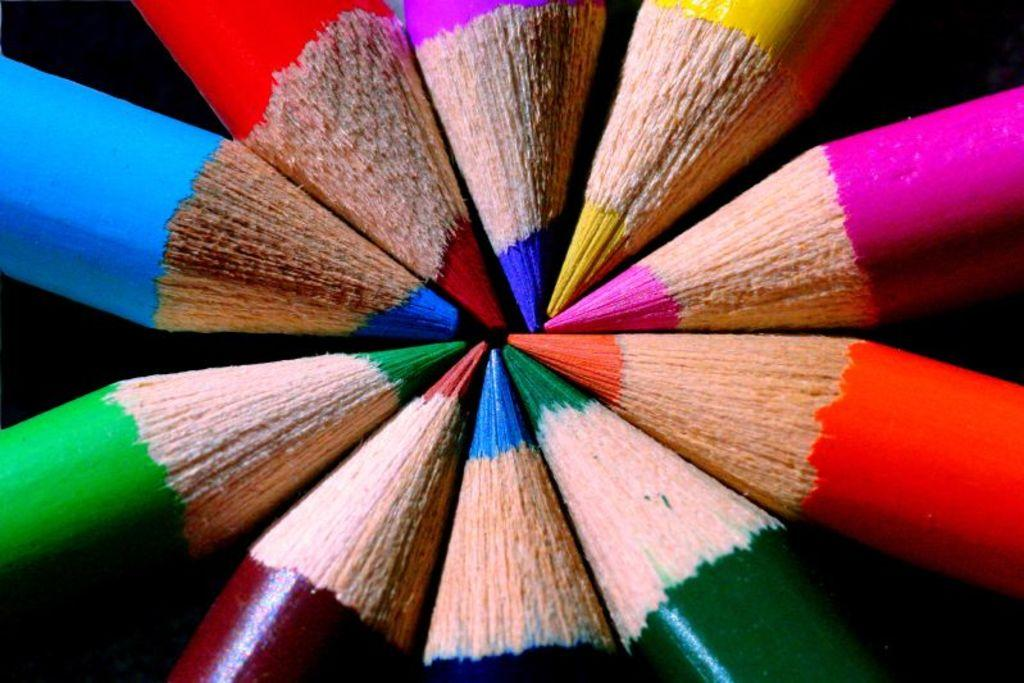What objects are present in the image? There are color pencils in the image. How are the color pencils arranged? The color pencils are arranged in a circular shape. What can be observed about the background of the image? The background of the image is dark. What type of eggnog is being served in the image? There is no eggnog present in the image; it features color pencils arranged in a circular shape. What mailbox is visible in the image? There is no mailbox present in the image; it only contains color pencils arranged in a circular shape. 